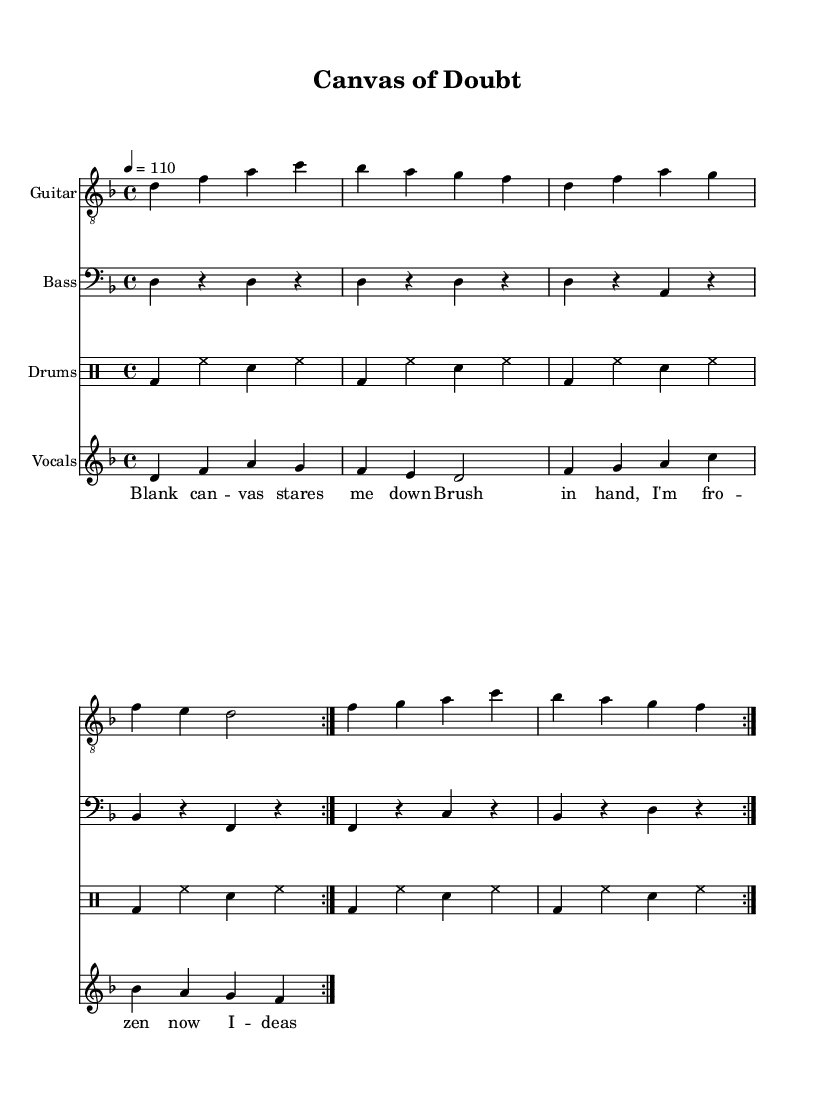What is the key signature of this music? The key signature is indicated by the placement of sharps or flats at the beginning of the staff. In this case, there are no sharps or flats shown, meaning it is in D minor which is the related minor for F major with one flat.
Answer: D minor What is the time signature of this music? The time signature is found at the beginning of the score, showing how many beats are in each measure. Here, it is indicated as 4/4, meaning there are four beats per measure.
Answer: 4/4 What is the tempo of this music? The tempo is indicated at the beginning of the score where it specifies a speed for the music, here it is marked as 4 = 110, which refers to the quarter note being played at 110 beats per minute.
Answer: 110 How many times is the verse repeated? The sheet indicates that the verse section is repeated with the notation \repeat volta 2. This notation signifies that the specific section is intended to be played twice.
Answer: 2 Which instrument plays the melody? By evaluating the score's structure, the vocals are marked as a separate staff, indicating that they provide the primary melodic line throughout the piece, as notated in the lyrics and vocal part.
Answer: Vocals What are the main themes expressed in the lyrics? Analyzing the lyrics reveals themes of artistic struggle and creation, where phrases like "Doubt and fear, they linger" suggest an internal confrontation, while "Through the struggle, beauty flows" emphasizes the value of perseverance in art-making.
Answer: Artistic struggle and creation How many distinct musical sections are present in this piece? Each section has a verse and a chorus, and they both are repeated. This means there are two distinct musical sections, each contributing to the overall structure which can be noted in the repetitive notation.
Answer: 2 